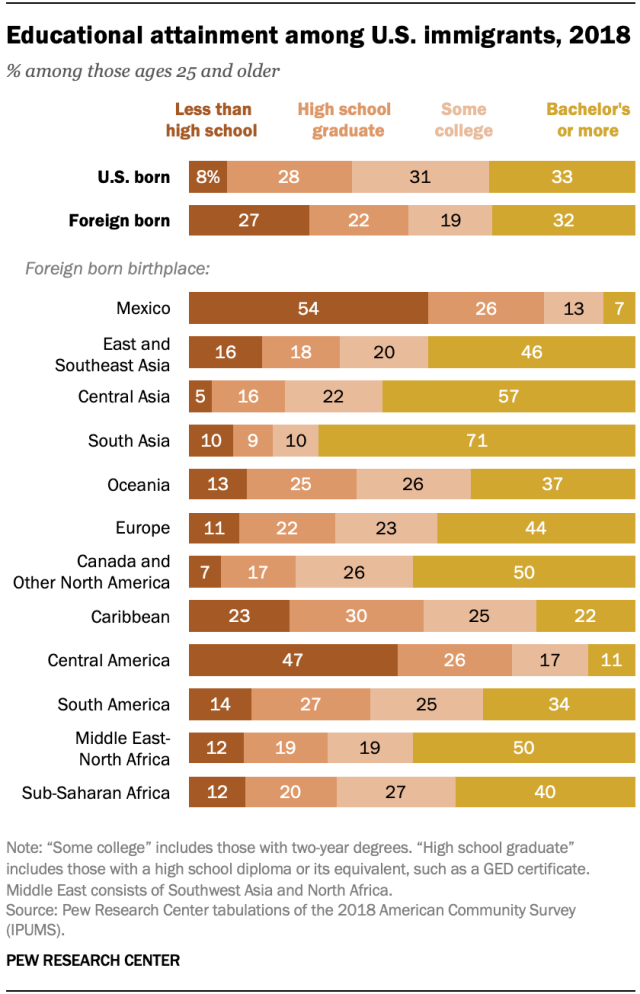Identify some key points in this picture. The median of all the bars in Mexico is 90.5. The largest value in the yellow graph is also 90.5. The number of types of bars used to represent a graph is 4. 